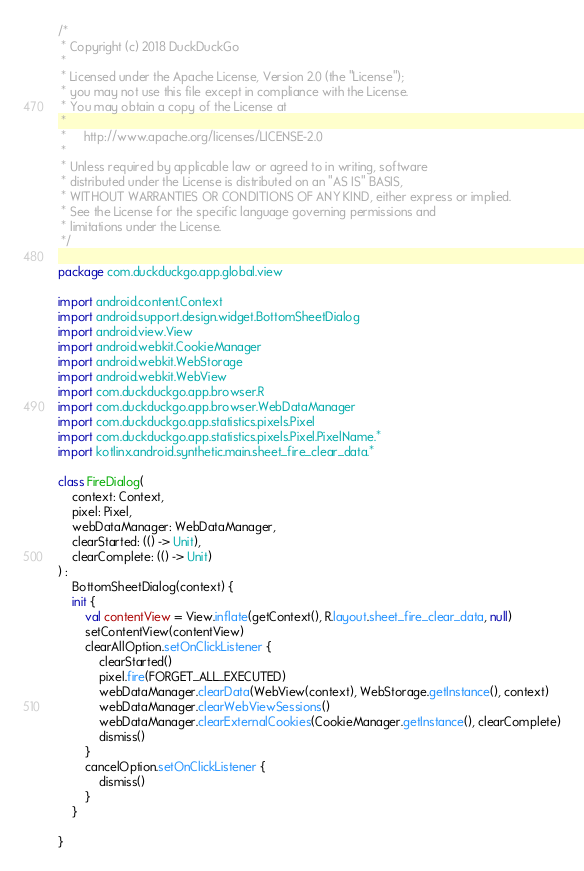Convert code to text. <code><loc_0><loc_0><loc_500><loc_500><_Kotlin_>/*
 * Copyright (c) 2018 DuckDuckGo
 *
 * Licensed under the Apache License, Version 2.0 (the "License");
 * you may not use this file except in compliance with the License.
 * You may obtain a copy of the License at
 *
 *     http://www.apache.org/licenses/LICENSE-2.0
 *
 * Unless required by applicable law or agreed to in writing, software
 * distributed under the License is distributed on an "AS IS" BASIS,
 * WITHOUT WARRANTIES OR CONDITIONS OF ANY KIND, either express or implied.
 * See the License for the specific language governing permissions and
 * limitations under the License.
 */

package com.duckduckgo.app.global.view

import android.content.Context
import android.support.design.widget.BottomSheetDialog
import android.view.View
import android.webkit.CookieManager
import android.webkit.WebStorage
import android.webkit.WebView
import com.duckduckgo.app.browser.R
import com.duckduckgo.app.browser.WebDataManager
import com.duckduckgo.app.statistics.pixels.Pixel
import com.duckduckgo.app.statistics.pixels.Pixel.PixelName.*
import kotlinx.android.synthetic.main.sheet_fire_clear_data.*

class FireDialog(
    context: Context,
    pixel: Pixel,
    webDataManager: WebDataManager,
    clearStarted: (() -> Unit),
    clearComplete: (() -> Unit)
) :
    BottomSheetDialog(context) {
    init {
        val contentView = View.inflate(getContext(), R.layout.sheet_fire_clear_data, null)
        setContentView(contentView)
        clearAllOption.setOnClickListener {
            clearStarted()
            pixel.fire(FORGET_ALL_EXECUTED)
            webDataManager.clearData(WebView(context), WebStorage.getInstance(), context)
            webDataManager.clearWebViewSessions()
            webDataManager.clearExternalCookies(CookieManager.getInstance(), clearComplete)
            dismiss()
        }
        cancelOption.setOnClickListener {
            dismiss()
        }
    }

}</code> 